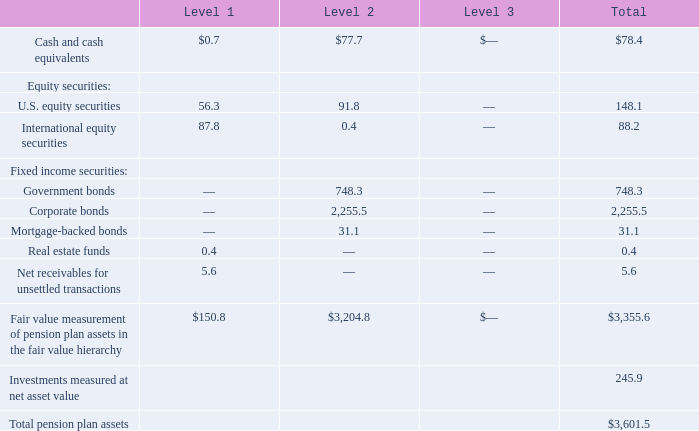Plan Assets  The fair value of plan assets, summarized by level within the fair value hierarchy described in Note 20, as of May 26, 2019, was as follows:
Level 1 assets are valued based on quoted prices in active markets for identical securities. The majority of the Level 1 assets listed above include the common stock of both U.S. and international companies, mutual funds, master limited partnership units, and real estate investment trusts, all of which are actively traded and priced in the market.
Level 2 assets are valued based on other significant observable inputs including quoted prices for similar securities, yield curves, indices, etc. Level 2 assets consist primarily of individual fixed income securities where values are based on quoted prices of similar securities and observable market data.
Level 3 assets consist of investments where active market pricing is not readily available and, as such, fair value is estimated using significant unobservable inputs.
Certain assets that are measured at fair value using the NAV (net asset value) per share (or its equivalent) practical expedient have not been classified in the fair value hierarchy. Such investments are generally considered long-term in nature with varying redemption availability. For certain of these investments, with a fair value of approximately $51.0 million as of May 26, 2019, the asset managers have the ability to impose customary redemption gates which may further restrict or limit the redemption of invested funds therein. As of May 26, 2019, funds with a fair value of $4.2 million have imposed such gates.
As of May 26, 2019, we have unfunded commitments for additional investments of $48.3 million in private equity funds and $17.0 million in natural resources funds. We expect unfunded commitments to be funded from plan assets rather than the general assets of the Company.
Notes to Consolidated Financial Statements - (Continued) Fiscal Years Ended May 26, 2019, May 27, 2018, and May 28, 2017 (columnar dollars in millions except per share amounts)
What are Level 1 assets valued based on? Quoted prices in active markets for identical securities. How much was the total pension plan assets (in millions) as of May 26, 2019? $3,601.5. How much were the fair values of Level 1 and 2 cash and cash equivalents assets, respectively?
Answer scale should be: million. $0.7, $77.7. What is the proportion of total fixed income securities over total pension plan assets? (748.3+2,255.5+31.1)/3,601.5 
Answer: 0.84. What is the ratio of Level 1 assets to Level 2 assets? 150.8/3,204.8 
Answer: 0.05. What is the ratio (in percentage) of the fair value of the customary redemption gates over total pension plan assets as of May 26, 2019?
Answer scale should be: percent. 4.2 / 3,601.5 
Answer: 0.12. 